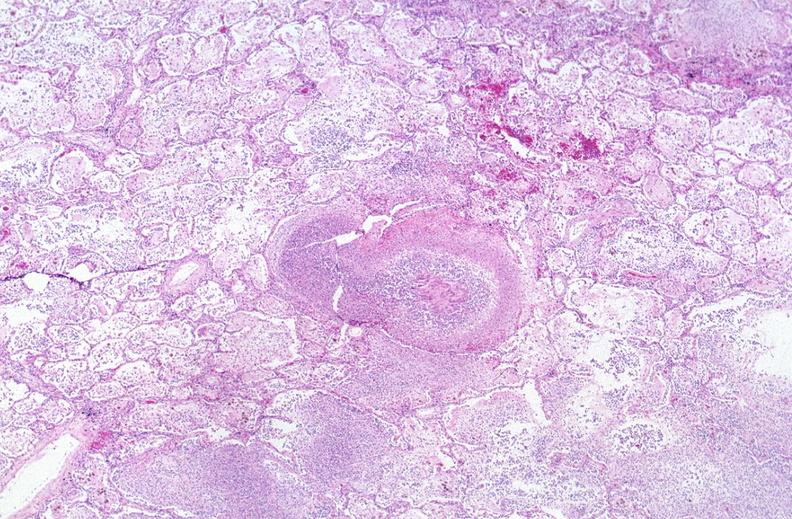s respiratory present?
Answer the question using a single word or phrase. Yes 